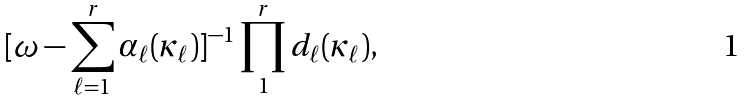<formula> <loc_0><loc_0><loc_500><loc_500>[ \omega - \sum _ { \ell = 1 } ^ { r } \alpha _ { \ell } ( \kappa _ { \ell } ) ] ^ { - 1 } \prod _ { 1 } ^ { r } d _ { \ell } ( \kappa _ { \ell } ) ,</formula> 